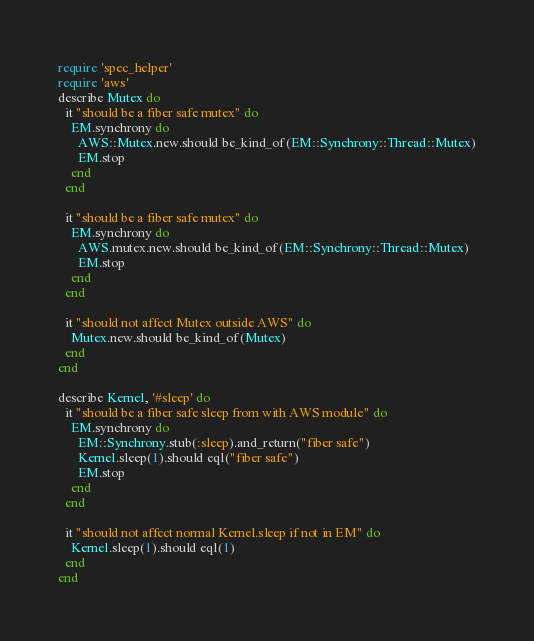<code> <loc_0><loc_0><loc_500><loc_500><_Ruby_>require 'spec_helper'
require 'aws'
describe Mutex do
  it "should be a fiber safe mutex" do
    EM.synchrony do
      AWS::Mutex.new.should be_kind_of(EM::Synchrony::Thread::Mutex)
      EM.stop
    end
  end

  it "should be a fiber safe mutex" do
    EM.synchrony do
      AWS.mutex.new.should be_kind_of(EM::Synchrony::Thread::Mutex)
      EM.stop
    end
  end

  it "should not affect Mutex outside AWS" do
    Mutex.new.should be_kind_of(Mutex)
  end
end

describe Kernel, '#sleep' do
  it "should be a fiber safe sleep from with AWS module" do
    EM.synchrony do
      EM::Synchrony.stub(:sleep).and_return("fiber safe")
      Kernel.sleep(1).should eql("fiber safe")
      EM.stop
    end
  end

  it "should not affect normal Kernel.sleep if not in EM" do
    Kernel.sleep(1).should eql(1)
  end
end
</code> 